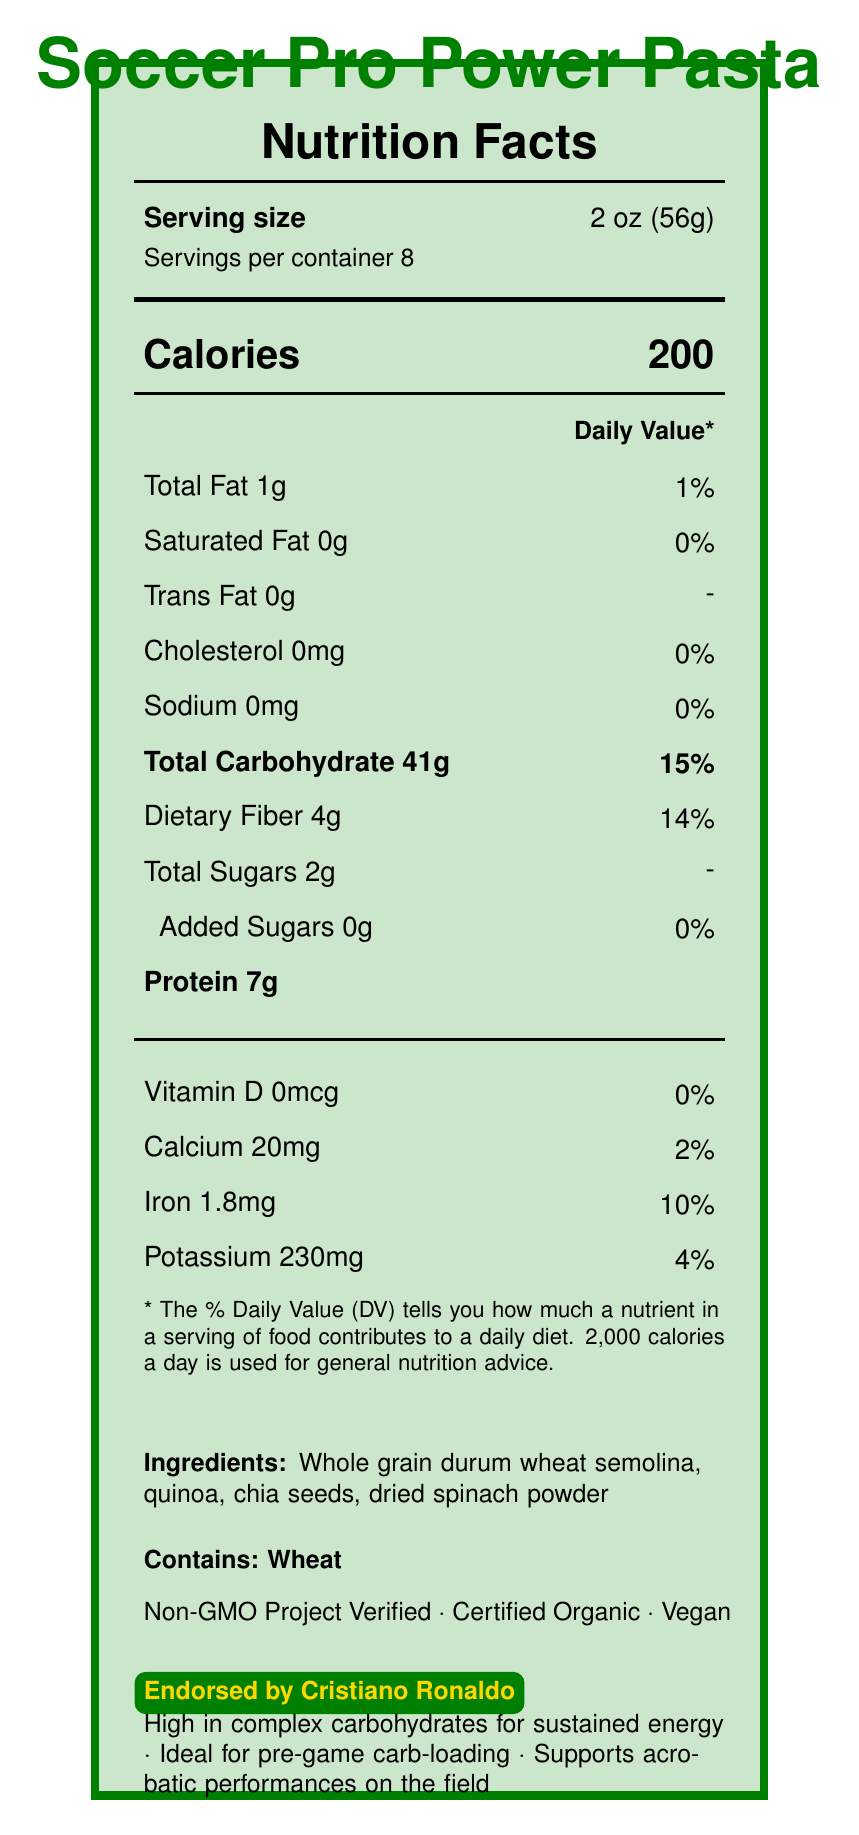what is the serving size? The serving size is specified as 2 oz (56g) in the document.
Answer: 2 oz (56g) how many servings are in a container of the pasta? The document lists that there are 8 servings per container.
Answer: 8 how many calories are in one serving? Each serving of the pasta contains 200 calories as noted in the document.
Answer: 200 what are the ingredients in this pasta? The ingredients are listed at the bottom of the document.
Answer: Whole grain durum wheat semolina, quinoa, chia seeds, dried spinach powder how much protein does one serving contain? The document indicates that one serving contains 7g of protein.
Answer: 7g which nutrient contributes 15% to the daily value based on one serving? The total carbohydrate content contributes 15% to the daily value per serving.
Answer: Total Carbohydrate how much iron is in one serving? A. 1mg B. 1.8mg C. 2.4mg D. 3mg The document details that one serving contains 1.8mg of iron, which is 10% daily value.
Answer: B which certification is not mentioned in the document? I. Non-GMO Project Verified II. Kosher III. Certified Organic IV. Vegan The document does not mention a Kosher certification; it mentions Non-GMO Project Verified, Certified Organic, and Vegan certifications.
Answer: II is the pasta recommended for pre-game carb-loading? The document claims that the pasta is ideal for pre-game carb-loading.
Answer: Yes does the pasta contain any added sugars? The document specifies that the pasta contains 0g of added sugars.
Answer: No summarize the main claims about this pasta The summary explanation includes all the main claims outlined in the bottom section of the document.
Answer: The document claims that Soccer Pro Power Pasta is high in complex carbohydrates for sustained energy, ideal for pre-game carb-loading, and supports acrobatic performances on the field. who prepared this product? The document does not mention who prepared the product. It only provides the product name, Nutrition Facts, ingredients, and some claims.
Answer: Not enough information 